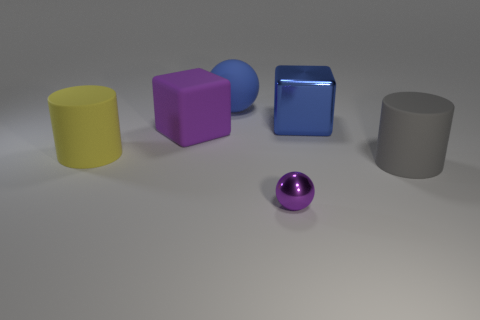Add 2 big blue cubes. How many objects exist? 8 Subtract all spheres. How many objects are left? 4 Add 4 metallic blocks. How many metallic blocks exist? 5 Subtract 1 purple balls. How many objects are left? 5 Subtract all large yellow metallic blocks. Subtract all large blue cubes. How many objects are left? 5 Add 4 blue rubber objects. How many blue rubber objects are left? 5 